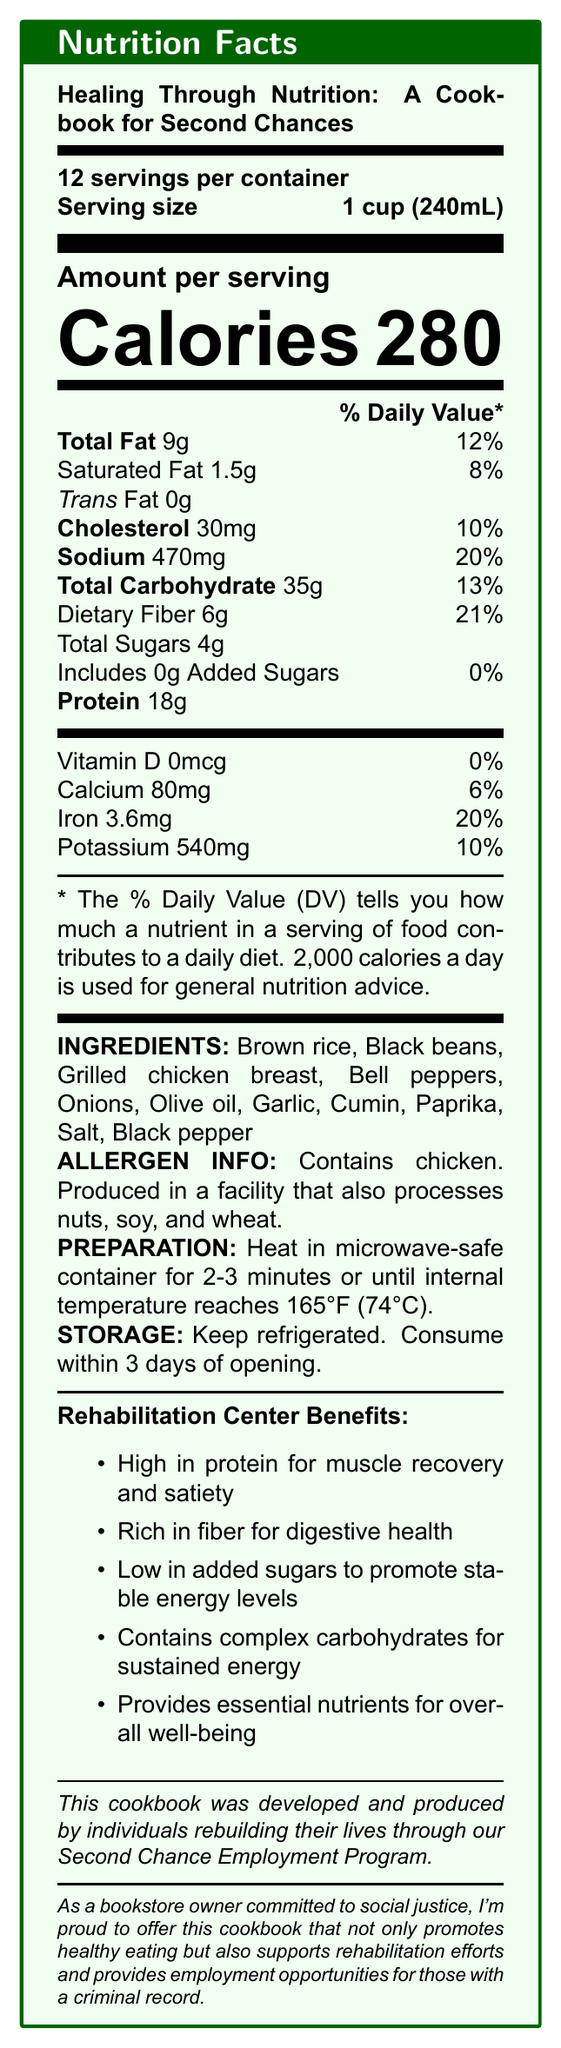what is the serving size for this cookbook product? The serving size is explicitly stated as 1 cup (240mL).
Answer: 1 cup (240mL) how many servings are in each container? The document mentions there are 12 servings per container.
Answer: 12 what is the total fat content per serving? According to the document, the total fat content per serving is 9g.
Answer: 9g does this product contain any trans fat? The document lists trans fat as 0g, indicating there is no trans fat.
Answer: No how much protein does each serving provide? The document states that each serving provides 18g of protein.
Answer: 18g how much calcium does this product contain per serving? The amount of calcium per serving is listed as 80mg.
Answer: 80mg what are the main ingredients in this product? The ingredients are clearly listed toward the bottom of the document.
Answer: Brown rice, Black beans, Grilled chicken breast, Bell peppers, Onions, Olive oil, Garlic, Cumin, Paprika, Salt, Black pepper what is the main message conveyed by the second chance employment program note? The note explicitly mentions that the cookbook was created by individuals who are part of the Second Chance Employment Program.
Answer: The cookbook was developed and produced by individuals rebuilding their lives through the Second Chance Employment Program. what vitamins and minerals does this product provide the least amount of? A. Vitamin D B. Calcium C. Iron D. Potassium The document lists Vitamin D as 0mcg (0% daily value), which is the lowest compared to the others.
Answer: A. Vitamin D what is the primary nutrient benefit mentioned for rehabilitation centers? A. High in protein B. Low sodium content C. High in calories D. High amount of added sugars The first benefit listed for rehabilitation centers is that the product is high in protein, which is important for muscle recovery and satiety.
Answer: A. High in protein is this product suitable for individuals looking to avoid added sugars? There are 0g of added sugars in this product, which is ideal for individuals aiming to avoid added sugars.
Answer: Yes what are the preparation instructions for this product? The preparation instructions clearly state to heat the product in a microwave-safe container for 2-3 minutes until it reaches an internal temperature of 165°F (74°C).
Answer: Heat in microwave-safe container for 2-3 minutes or until internal temperature reaches 165°F (74°C). does the document mention any allergens? The allergen information indicates that the product contains chicken and is produced in a facility that also processes nuts, soy, and wheat.
Answer: Yes what is the main idea of this document? The entire document focuses on the nutrition information, health benefits, and social impact of the cookbook product.
Answer: The document provides nutrition facts for a cookbook product designed for rehabilitation centers, emphasizing its health benefits and the social impact of its production by individuals in the Second Chance Employment Program. how many grams of total sugars are added to this product? The document only states the total sugars (4g) but does not clarify how much of it is naturally occurring versus added.
Answer: Cannot be determined how should this product be stored after opening? The document states that this product should be kept refrigerated and consumed within 3 days of opening.
Answer: Keep refrigerated. Consume within 3 days of opening. 